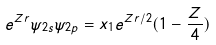<formula> <loc_0><loc_0><loc_500><loc_500>e ^ { Z r } \psi _ { 2 s } \psi _ { 2 p } = x _ { 1 } e ^ { Z r / 2 } ( 1 - \frac { Z } { 4 } )</formula> 